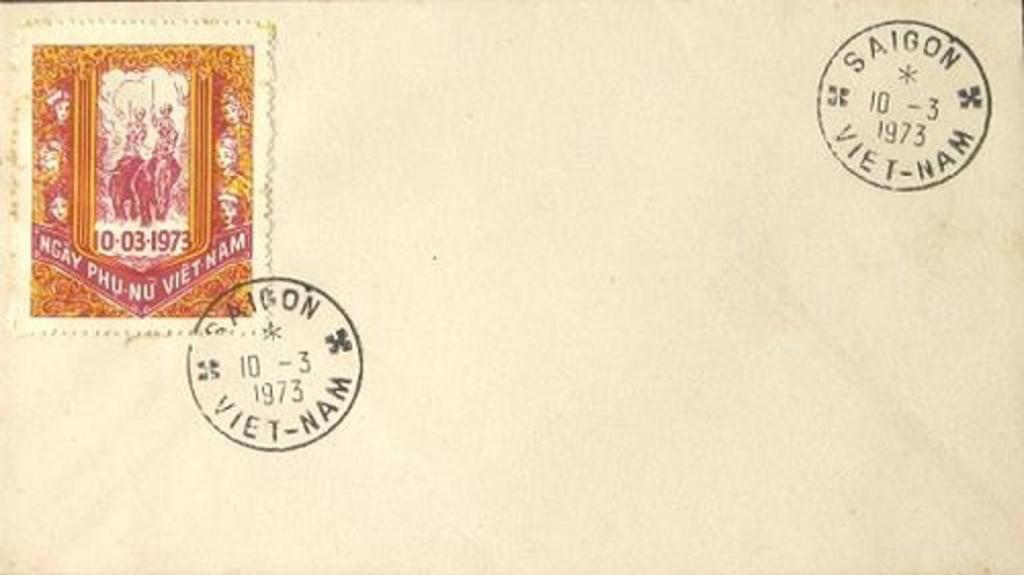<image>
Render a clear and concise summary of the photo. A blank envelope has a pink and orange stamp from Vietnam on the front 